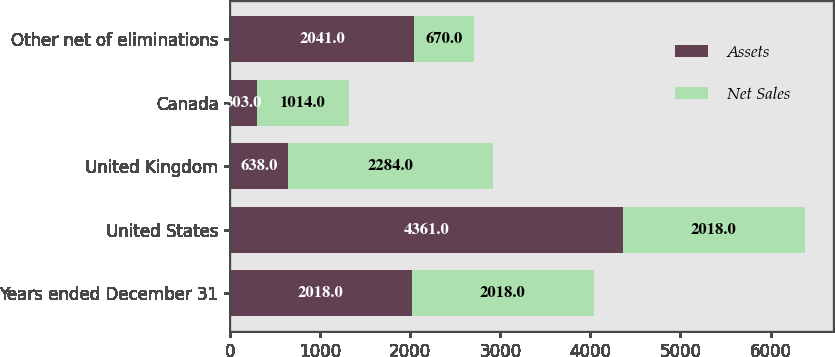Convert chart. <chart><loc_0><loc_0><loc_500><loc_500><stacked_bar_chart><ecel><fcel>Years ended December 31<fcel>United States<fcel>United Kingdom<fcel>Canada<fcel>Other net of eliminations<nl><fcel>Assets<fcel>2018<fcel>4361<fcel>638<fcel>303<fcel>2041<nl><fcel>Net Sales<fcel>2018<fcel>2018<fcel>2284<fcel>1014<fcel>670<nl></chart> 